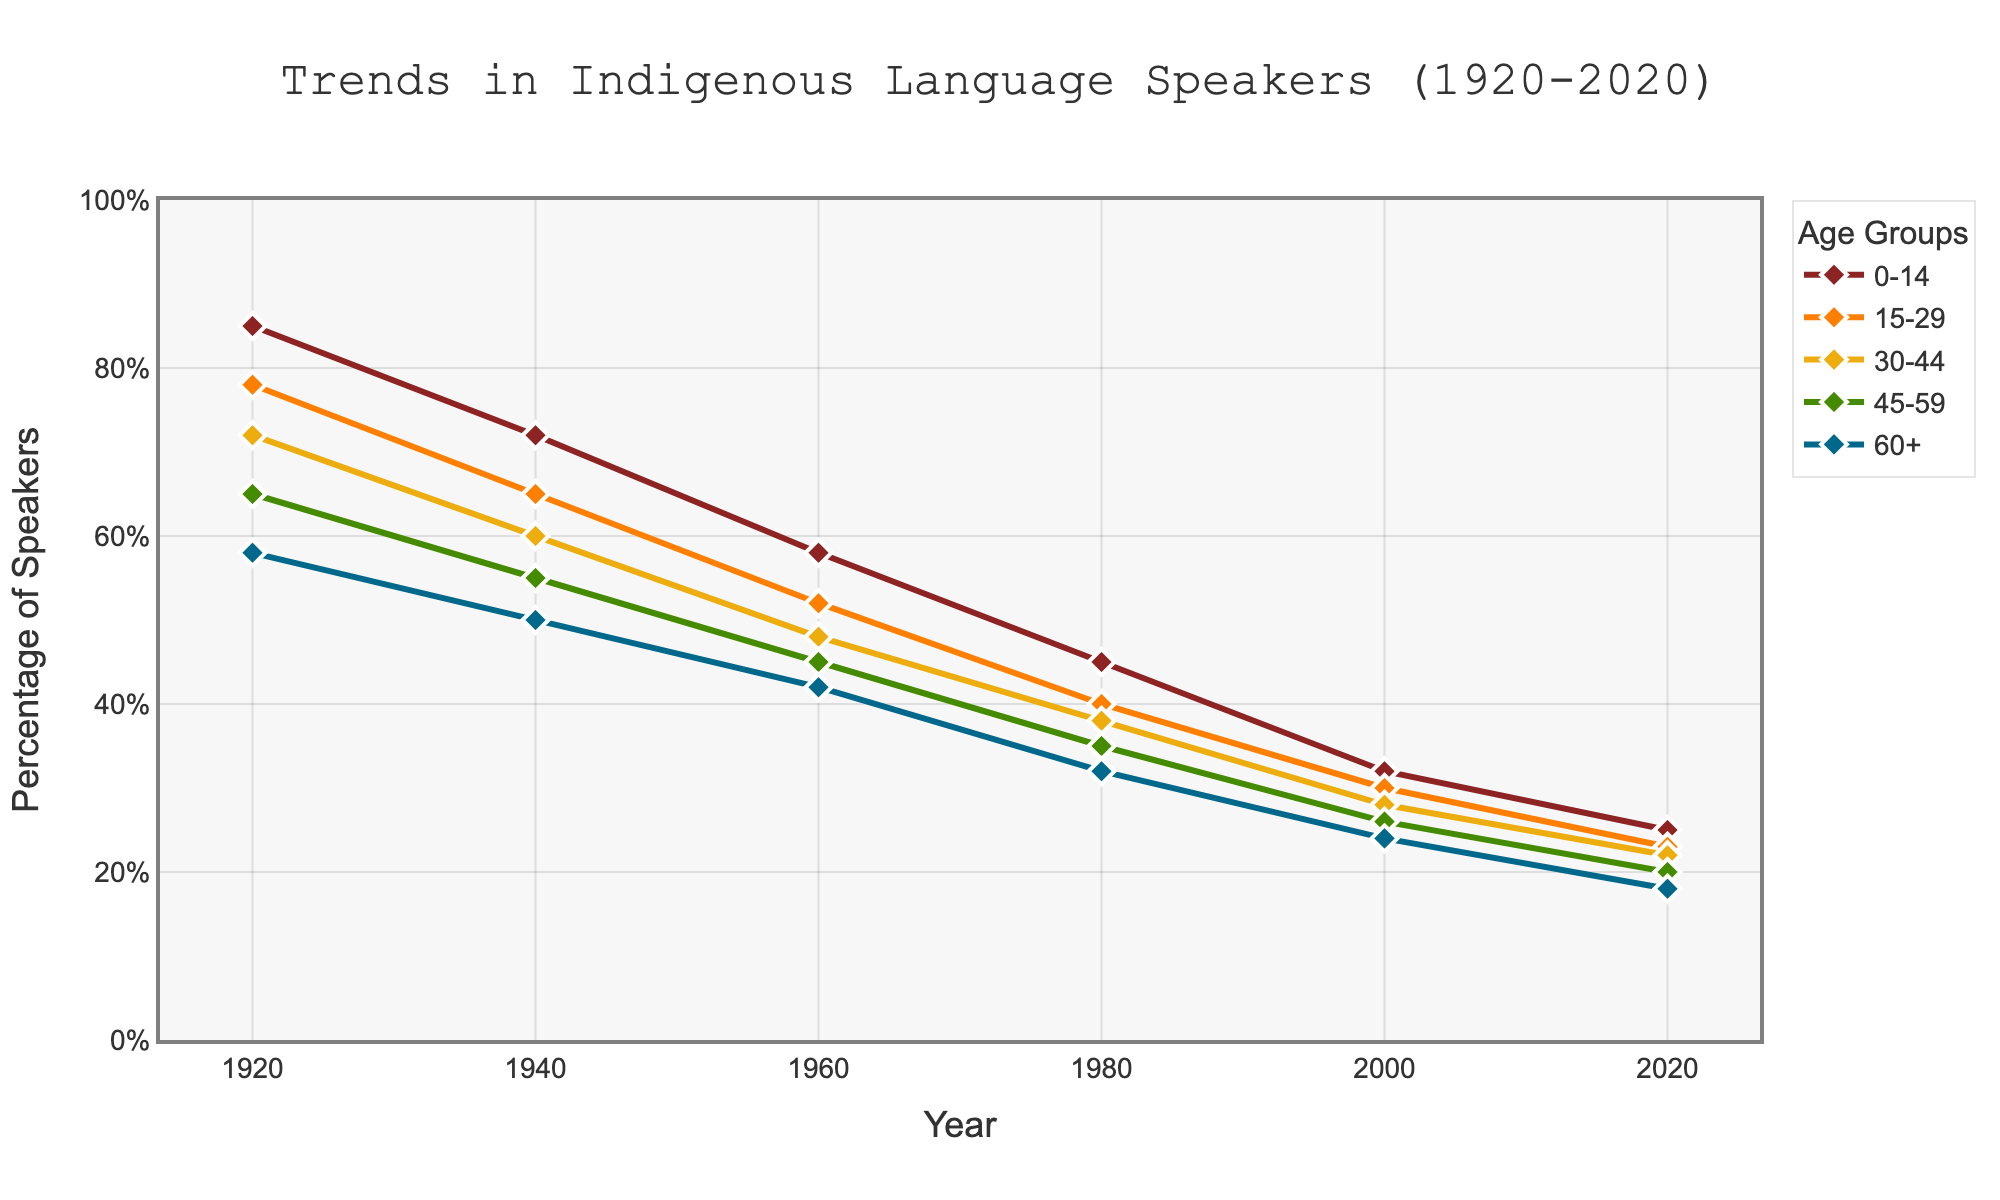What's the overall trend in the percentage of indigenous language speakers across all age groups from 1920 to 2020? By looking at the trend lines, all age groups show a decline over time. The lines consistently move downward as the years progress from 1920 to 2020, indicating a decrease in the percentage of speakers.
Answer: Decline Which age group had the highest percentage of indigenous language speakers in 1920? Looking at the marks for 1920 on the y-axis, the age group '0-14' had the highest percentage marked at 85%.
Answer: 0-14 What percentage of speakers does the 60+ age group have in 2020? Check the value on the y-axis for the line corresponding to the '60+' age group at the year 2020. The graph shows this percentage as 18%.
Answer: 18% Compare the percentage of speakers in the 0-14 and 30-44 age groups in the year 1980. Locate the points for 1980 on the lines for the '0-14' and '30-44' age groups, and read the values. The '0-14' age group is at 45%, and the '30-44' age group is at 38%.
Answer: 0-14 has 7% more than 30-44 What's the average percentage of indigenous language speakers across all age groups in 1940? Sum the values for all age groups in 1940 and divide by the number of age groups (5). (72 + 65 + 60 + 55 + 50) / 5 = 60.4
Answer: 60.4 How did the percentage of speakers in the 15-29 age group change from 1960 to 2000? Find the values for 1960 (52%) and 2000 (30%), then calculate the difference. 52% - 30% = 22% decline.
Answer: Decline by 22% What's the visual attribute that helps identify the 15-29 age group's line in the plot? The 15-29 age group's line can be identified by its orange color and the markers used are diamonds outlined in white.
Answer: Orange line with diamond markers Which age group shows the steepest decline over the century? By examining the slopes of the lines from 1920 to 2020, the '0-14' age group shows the steepest decline, from 85% to 25%, a 60% decline.
Answer: 0-14 What is the difference in the percentage of speakers between the 45-59 and 60+ age groups in 1920? Find the values for 1920 for both age groups (65% for 45-59 and 58% for 60+), then calculate the difference. 65% - 58% = 7%.
Answer: 7% By how much did the percentage of speakers in the 30-44 age group decrease between 1980 and 2020? Check the values for the 30-44 age group in 1980 (38%) and 2020 (22%), then find the difference. 38% - 22% = 16%.
Answer: 16% 